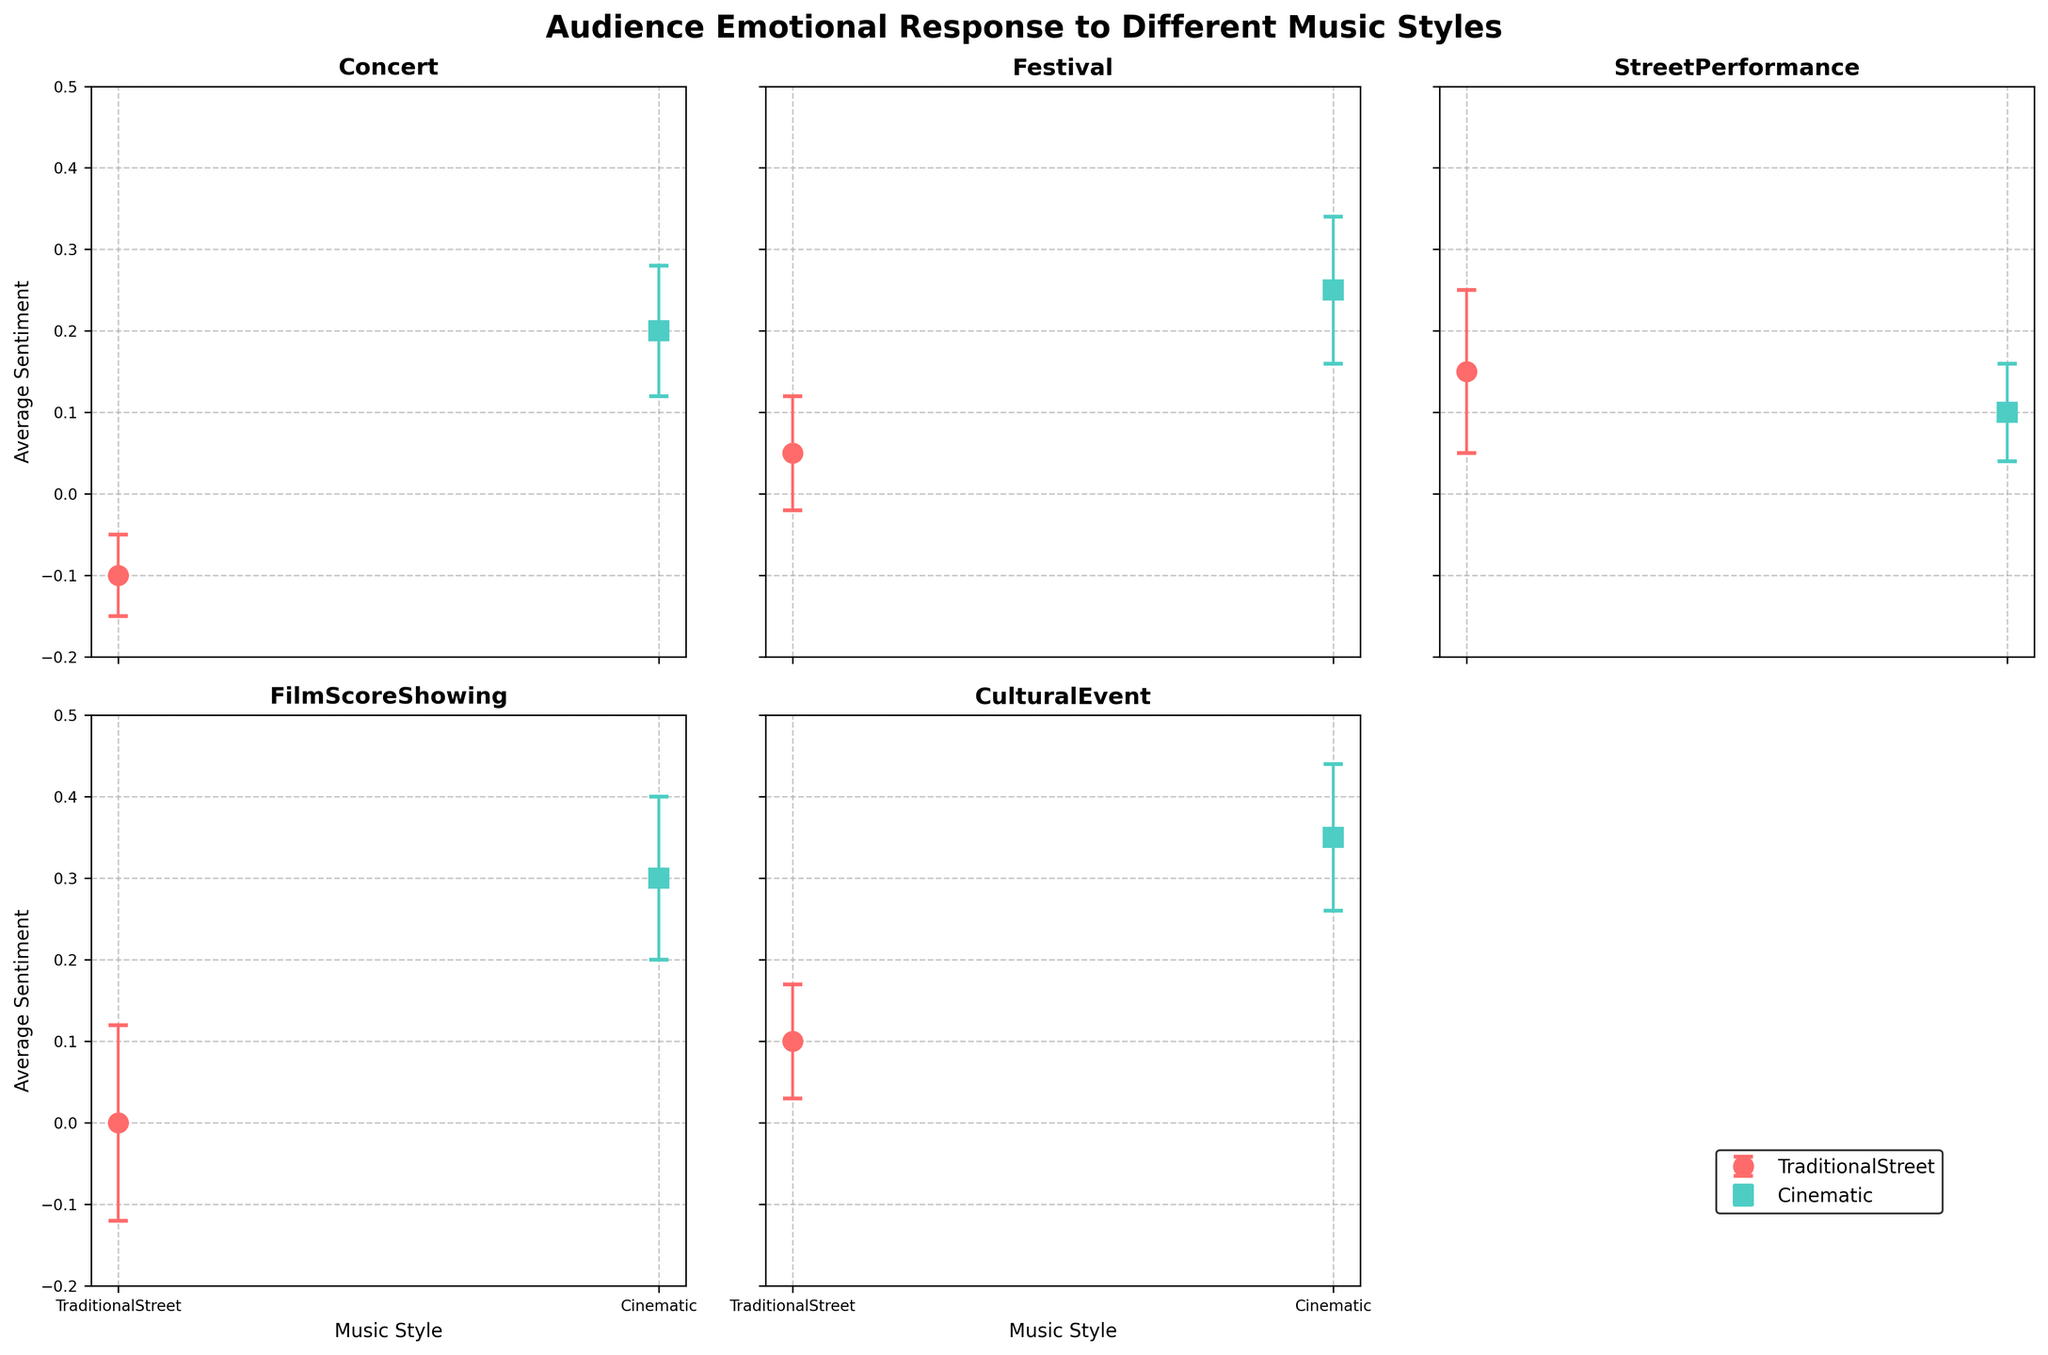What's the title of the figure? The title is displayed at the top of the figure in larger, bold font. The title provides a summary of the plot's content. In this case, it reads "Audience Emotional Response to Different Music Styles".
Answer: Audience Emotional Response to Different Music Styles Which event shows the highest average sentiment for Cinematic music style? By examining each subplot, we see that the Cultural Event has the highest average sentiment for Cinematic music, reaching 0.35.
Answer: Cultural Event What is the average sentiment for Traditional Street music at the Concert event? For the Concert event subplot, we locate the data point for TraditionalStreet music. The sentiment is plotted at -0.10.
Answer: -0.10 How does the average sentiment for Traditional Street music at Cultural Event compare to that at Street Performance? Comparing the Traditional Street music average sentiment at Cultural Event (0.10) and Street Performance (0.15) shows that the sentiment at Street Performance is higher.
Answer: Street Performance is higher Which music style shows the greatest variation in audience emotional response at FilmScoreShowing? By comparing the size of the error bars in the FilmScoreShowing subplot, the Traditional Street music style has a larger error bar (0.12) than Cinematic, which has an error bar of (0.10), indicating greater variation.
Answer: Traditional Street What is the difference in average sentiment for Cinematic music between FilmScoreShowing and Festival? The average sentiment for Cinematic music is 0.30 at FilmScoreShowing and 0.25 at Festival. The difference is 0.30 - 0.25 = 0.05.
Answer: 0.05 Which music style and event combination has the lowest average sentiment? By scanning all the subplots, the lowest average sentiment is for Traditional Street music at Concert, which is -0.10.
Answer: Traditional Street at Concert How does the sentiment for Cinematic music at StreetPerformance compare to the sentiment for Traditional Street music at the same event? For the StreetPerformance event, the sentiment for Cinematic music is 0.10 and for Traditional Street music is 0.15. Traditional Street music has a higher sentiment.
Answer: Traditional Street is higher What is the range of average sentiments for Traditional Street music across all events? The range is calculated by finding the difference between the highest and lowest average sentiments. The highest is 0.15 (StreetPerformance) and the lowest is -0.10 (Concert). The range is 0.15 - (-0.10) = 0.25.
Answer: 0.25 What does the error bar represent in these plots? Error bars represent the standard deviation of the sentiment values, showing the variation or uncertainty in the audience's emotional response for each music style at different events.
Answer: Variation in audience emotional response 